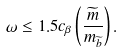<formula> <loc_0><loc_0><loc_500><loc_500>\omega \leq 1 . 5 c _ { \beta } \left ( \frac { \widetilde { m } } { m _ { \widetilde { b } } } \right ) .</formula> 